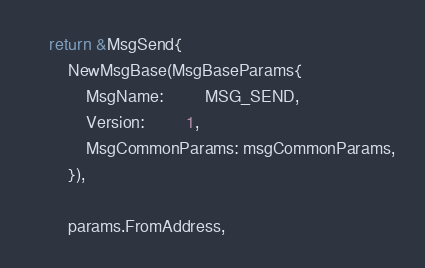<code> <loc_0><loc_0><loc_500><loc_500><_Go_>	return &MsgSend{
		NewMsgBase(MsgBaseParams{
			MsgName:         MSG_SEND,
			Version:         1,
			MsgCommonParams: msgCommonParams,
		}),

		params.FromAddress,</code> 